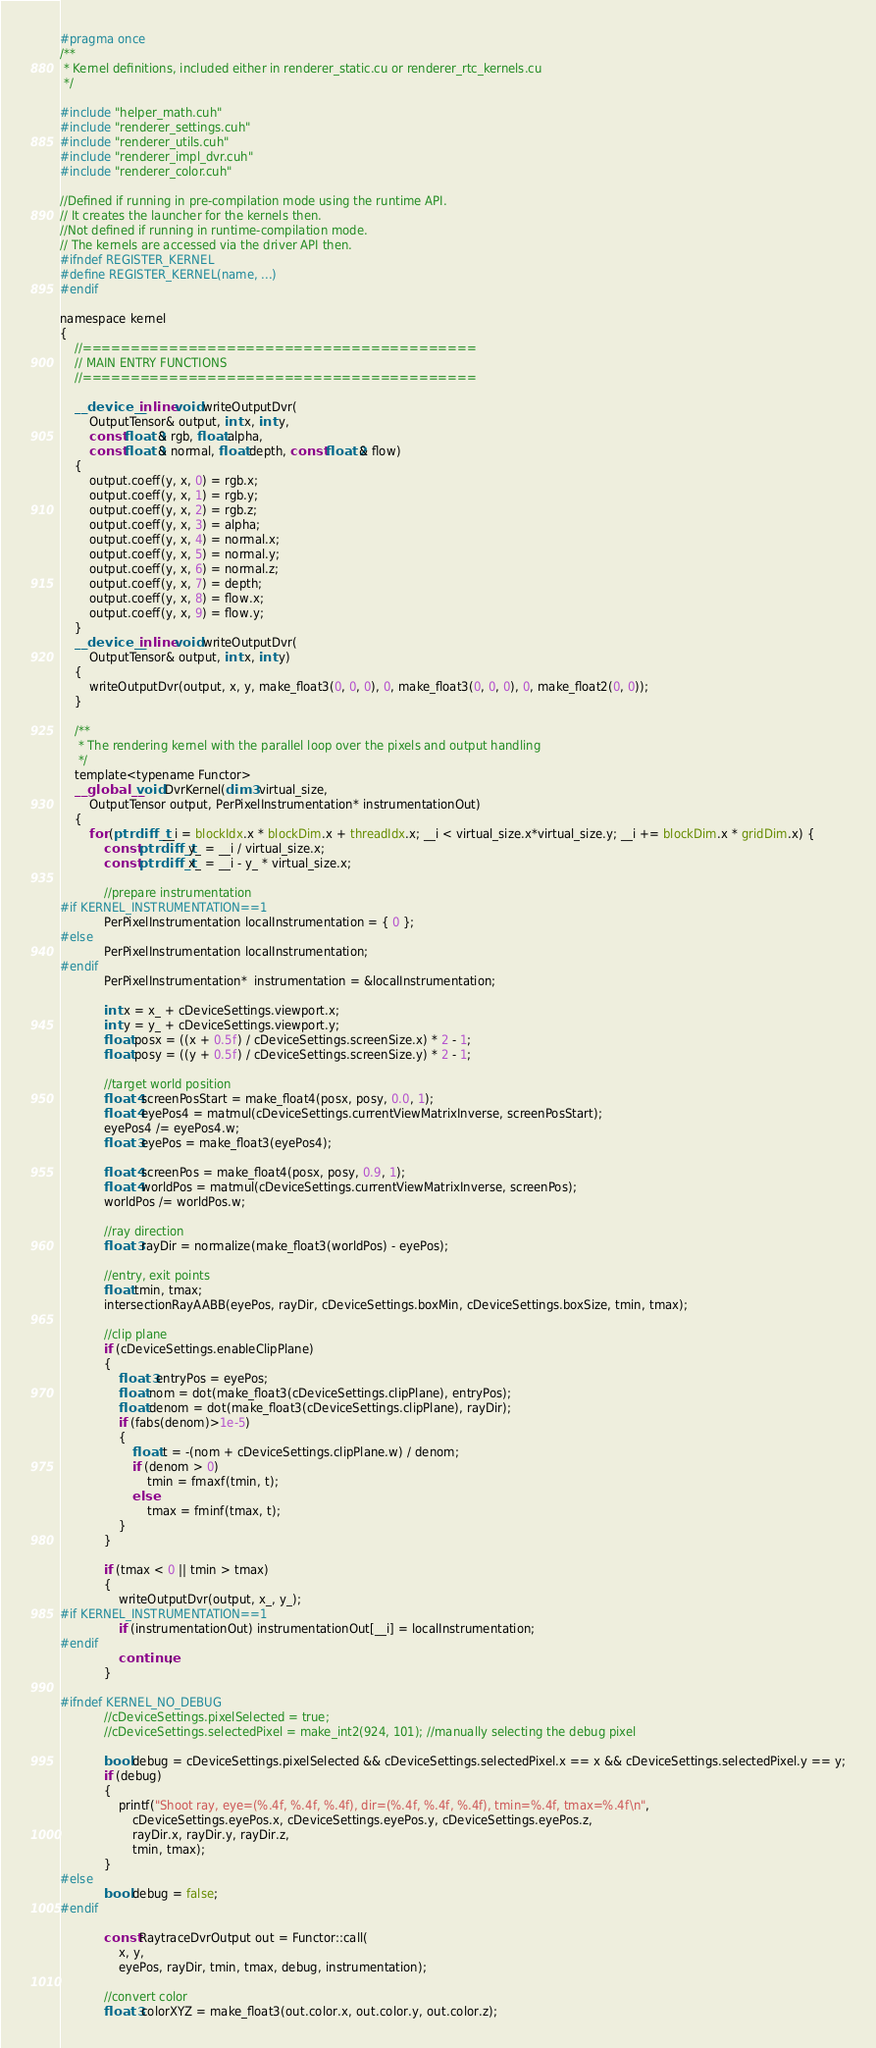<code> <loc_0><loc_0><loc_500><loc_500><_Cuda_>#pragma once
/**
 * Kernel definitions, included either in renderer_static.cu or renderer_rtc_kernels.cu
 */

#include "helper_math.cuh"
#include "renderer_settings.cuh"
#include "renderer_utils.cuh"
#include "renderer_impl_dvr.cuh"
#include "renderer_color.cuh"

//Defined if running in pre-compilation mode using the runtime API.
// It creates the launcher for the kernels then.
//Not defined if running in runtime-compilation mode.
// The kernels are accessed via the driver API then.
#ifndef REGISTER_KERNEL
#define REGISTER_KERNEL(name, ...)
#endif

namespace kernel
{
	//=========================================
	// MAIN ENTRY FUNCTIONS
	//=========================================

	__device__ inline void writeOutputDvr(
		OutputTensor& output, int x, int y,
		const float3& rgb, float alpha,
		const float3& normal, float depth, const float2& flow)
	{
		output.coeff(y, x, 0) = rgb.x;
		output.coeff(y, x, 1) = rgb.y;
		output.coeff(y, x, 2) = rgb.z;
		output.coeff(y, x, 3) = alpha;
		output.coeff(y, x, 4) = normal.x;
		output.coeff(y, x, 5) = normal.y;
		output.coeff(y, x, 6) = normal.z;
		output.coeff(y, x, 7) = depth;
		output.coeff(y, x, 8) = flow.x;
		output.coeff(y, x, 9) = flow.y;
	}
	__device__ inline void writeOutputDvr(
		OutputTensor& output, int x, int y)
	{
		writeOutputDvr(output, x, y, make_float3(0, 0, 0), 0, make_float3(0, 0, 0), 0, make_float2(0, 0));
	}

	/**
	 * The rendering kernel with the parallel loop over the pixels and output handling
	 */
	template<typename Functor>
	__global__ void DvrKernel(dim3 virtual_size,
		OutputTensor output, PerPixelInstrumentation* instrumentationOut)
	{
		for (ptrdiff_t __i = blockIdx.x * blockDim.x + threadIdx.x; __i < virtual_size.x*virtual_size.y; __i += blockDim.x * gridDim.x) {
			const ptrdiff_t y_ = __i / virtual_size.x;
			const ptrdiff_t x_ = __i - y_ * virtual_size.x;

			//prepare instrumentation
#if KERNEL_INSTRUMENTATION==1
			PerPixelInstrumentation localInstrumentation = { 0 };
#else
			PerPixelInstrumentation localInstrumentation;
#endif
			PerPixelInstrumentation*  instrumentation = &localInstrumentation;
			
			int x = x_ + cDeviceSettings.viewport.x;
			int y = y_ + cDeviceSettings.viewport.y;
			float posx = ((x + 0.5f) / cDeviceSettings.screenSize.x) * 2 - 1;
			float posy = ((y + 0.5f) / cDeviceSettings.screenSize.y) * 2 - 1;

			//target world position
			float4 screenPosStart = make_float4(posx, posy, 0.0, 1);
			float4 eyePos4 = matmul(cDeviceSettings.currentViewMatrixInverse, screenPosStart);
			eyePos4 /= eyePos4.w;
			float3 eyePos = make_float3(eyePos4);
			
			float4 screenPos = make_float4(posx, posy, 0.9, 1);
			float4 worldPos = matmul(cDeviceSettings.currentViewMatrixInverse, screenPos);
			worldPos /= worldPos.w;

			//ray direction
			float3 rayDir = normalize(make_float3(worldPos) - eyePos);

			//entry, exit points
			float tmin, tmax;
			intersectionRayAABB(eyePos, rayDir, cDeviceSettings.boxMin, cDeviceSettings.boxSize, tmin, tmax);
			
			//clip plane
			if (cDeviceSettings.enableClipPlane)
			{
				float3 entryPos = eyePos;
				float nom = dot(make_float3(cDeviceSettings.clipPlane), entryPos);
				float denom = dot(make_float3(cDeviceSettings.clipPlane), rayDir);
				if (fabs(denom)>1e-5)
				{
					float t = -(nom + cDeviceSettings.clipPlane.w) / denom;
					if (denom > 0)
						tmin = fmaxf(tmin, t);
					else
						tmax = fminf(tmax, t);
				}
			}

			if (tmax < 0 || tmin > tmax)
			{
				writeOutputDvr(output, x_, y_);
#if KERNEL_INSTRUMENTATION==1
				if (instrumentationOut) instrumentationOut[__i] = localInstrumentation;
#endif
				continue;
			}

#ifndef KERNEL_NO_DEBUG
			//cDeviceSettings.pixelSelected = true;
			//cDeviceSettings.selectedPixel = make_int2(924, 101); //manually selecting the debug pixel
			
			bool debug = cDeviceSettings.pixelSelected && cDeviceSettings.selectedPixel.x == x && cDeviceSettings.selectedPixel.y == y;
			if (debug)
			{
				printf("Shoot ray, eye=(%.4f, %.4f, %.4f), dir=(%.4f, %.4f, %.4f), tmin=%.4f, tmax=%.4f\n",
					cDeviceSettings.eyePos.x, cDeviceSettings.eyePos.y, cDeviceSettings.eyePos.z,
					rayDir.x, rayDir.y, rayDir.z,
					tmin, tmax);
			}
#else
			bool debug = false;
#endif
			
			const RaytraceDvrOutput out = Functor::call(
				x, y,
				eyePos, rayDir, tmin, tmax, debug, instrumentation);

			//convert color
			float3 colorXYZ = make_float3(out.color.x, out.color.y, out.color.z);</code> 